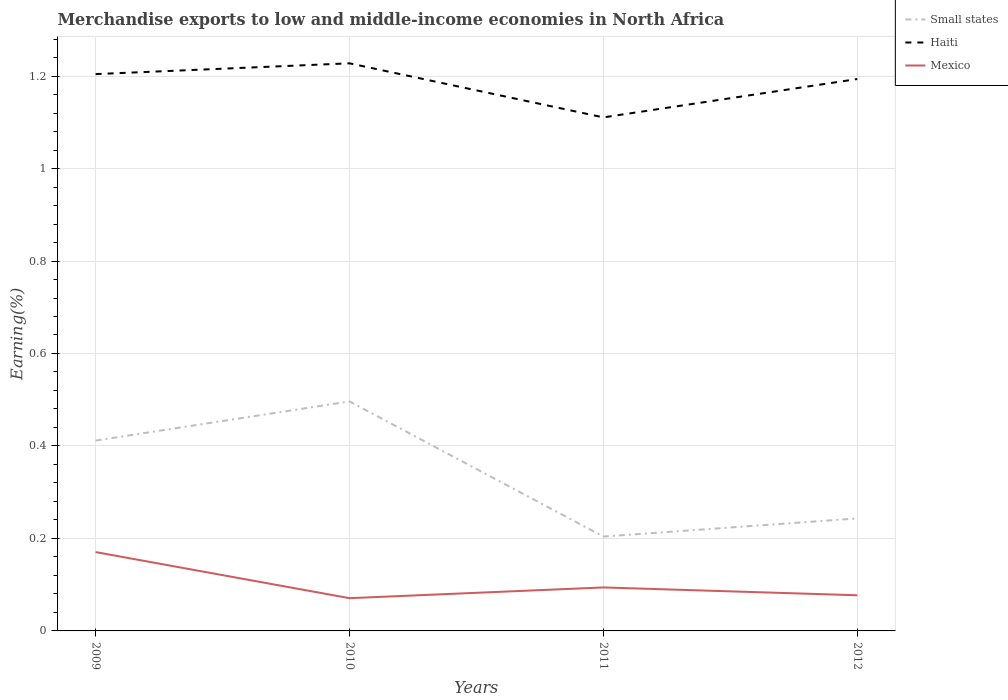Is the number of lines equal to the number of legend labels?
Provide a succinct answer. Yes. Across all years, what is the maximum percentage of amount earned from merchandise exports in Small states?
Make the answer very short. 0.2. In which year was the percentage of amount earned from merchandise exports in Haiti maximum?
Make the answer very short. 2011. What is the total percentage of amount earned from merchandise exports in Haiti in the graph?
Offer a very short reply. -0.02. What is the difference between the highest and the second highest percentage of amount earned from merchandise exports in Haiti?
Make the answer very short. 0.12. What is the difference between the highest and the lowest percentage of amount earned from merchandise exports in Small states?
Ensure brevity in your answer.  2. Is the percentage of amount earned from merchandise exports in Haiti strictly greater than the percentage of amount earned from merchandise exports in Small states over the years?
Your answer should be compact. No. How many lines are there?
Give a very brief answer. 3. Does the graph contain any zero values?
Provide a short and direct response. No. Where does the legend appear in the graph?
Your response must be concise. Top right. How many legend labels are there?
Ensure brevity in your answer.  3. What is the title of the graph?
Your answer should be compact. Merchandise exports to low and middle-income economies in North Africa. Does "Ghana" appear as one of the legend labels in the graph?
Ensure brevity in your answer.  No. What is the label or title of the Y-axis?
Give a very brief answer. Earning(%). What is the Earning(%) of Small states in 2009?
Your response must be concise. 0.41. What is the Earning(%) in Haiti in 2009?
Your answer should be compact. 1.2. What is the Earning(%) of Mexico in 2009?
Offer a very short reply. 0.17. What is the Earning(%) of Small states in 2010?
Make the answer very short. 0.5. What is the Earning(%) in Haiti in 2010?
Ensure brevity in your answer.  1.23. What is the Earning(%) of Mexico in 2010?
Make the answer very short. 0.07. What is the Earning(%) in Small states in 2011?
Provide a succinct answer. 0.2. What is the Earning(%) in Haiti in 2011?
Your answer should be very brief. 1.11. What is the Earning(%) in Mexico in 2011?
Give a very brief answer. 0.09. What is the Earning(%) of Small states in 2012?
Your answer should be compact. 0.24. What is the Earning(%) in Haiti in 2012?
Offer a terse response. 1.19. What is the Earning(%) of Mexico in 2012?
Your answer should be compact. 0.08. Across all years, what is the maximum Earning(%) of Small states?
Provide a short and direct response. 0.5. Across all years, what is the maximum Earning(%) in Haiti?
Your answer should be compact. 1.23. Across all years, what is the maximum Earning(%) in Mexico?
Give a very brief answer. 0.17. Across all years, what is the minimum Earning(%) in Small states?
Keep it short and to the point. 0.2. Across all years, what is the minimum Earning(%) of Haiti?
Your answer should be very brief. 1.11. Across all years, what is the minimum Earning(%) in Mexico?
Your answer should be very brief. 0.07. What is the total Earning(%) in Small states in the graph?
Your response must be concise. 1.36. What is the total Earning(%) in Haiti in the graph?
Give a very brief answer. 4.74. What is the total Earning(%) of Mexico in the graph?
Offer a very short reply. 0.41. What is the difference between the Earning(%) in Small states in 2009 and that in 2010?
Provide a succinct answer. -0.08. What is the difference between the Earning(%) in Haiti in 2009 and that in 2010?
Keep it short and to the point. -0.02. What is the difference between the Earning(%) in Mexico in 2009 and that in 2010?
Your answer should be compact. 0.1. What is the difference between the Earning(%) in Small states in 2009 and that in 2011?
Provide a short and direct response. 0.21. What is the difference between the Earning(%) in Haiti in 2009 and that in 2011?
Offer a very short reply. 0.09. What is the difference between the Earning(%) of Mexico in 2009 and that in 2011?
Provide a short and direct response. 0.08. What is the difference between the Earning(%) in Small states in 2009 and that in 2012?
Offer a terse response. 0.17. What is the difference between the Earning(%) of Haiti in 2009 and that in 2012?
Ensure brevity in your answer.  0.01. What is the difference between the Earning(%) of Mexico in 2009 and that in 2012?
Keep it short and to the point. 0.09. What is the difference between the Earning(%) of Small states in 2010 and that in 2011?
Offer a very short reply. 0.29. What is the difference between the Earning(%) of Haiti in 2010 and that in 2011?
Offer a terse response. 0.12. What is the difference between the Earning(%) of Mexico in 2010 and that in 2011?
Provide a succinct answer. -0.02. What is the difference between the Earning(%) of Small states in 2010 and that in 2012?
Keep it short and to the point. 0.25. What is the difference between the Earning(%) of Haiti in 2010 and that in 2012?
Ensure brevity in your answer.  0.03. What is the difference between the Earning(%) of Mexico in 2010 and that in 2012?
Ensure brevity in your answer.  -0.01. What is the difference between the Earning(%) of Small states in 2011 and that in 2012?
Offer a terse response. -0.04. What is the difference between the Earning(%) of Haiti in 2011 and that in 2012?
Your response must be concise. -0.08. What is the difference between the Earning(%) in Mexico in 2011 and that in 2012?
Ensure brevity in your answer.  0.02. What is the difference between the Earning(%) in Small states in 2009 and the Earning(%) in Haiti in 2010?
Keep it short and to the point. -0.82. What is the difference between the Earning(%) in Small states in 2009 and the Earning(%) in Mexico in 2010?
Your answer should be compact. 0.34. What is the difference between the Earning(%) of Haiti in 2009 and the Earning(%) of Mexico in 2010?
Provide a short and direct response. 1.13. What is the difference between the Earning(%) in Small states in 2009 and the Earning(%) in Haiti in 2011?
Provide a short and direct response. -0.7. What is the difference between the Earning(%) in Small states in 2009 and the Earning(%) in Mexico in 2011?
Provide a succinct answer. 0.32. What is the difference between the Earning(%) of Haiti in 2009 and the Earning(%) of Mexico in 2011?
Your answer should be very brief. 1.11. What is the difference between the Earning(%) of Small states in 2009 and the Earning(%) of Haiti in 2012?
Offer a terse response. -0.78. What is the difference between the Earning(%) of Small states in 2009 and the Earning(%) of Mexico in 2012?
Make the answer very short. 0.33. What is the difference between the Earning(%) of Haiti in 2009 and the Earning(%) of Mexico in 2012?
Your answer should be compact. 1.13. What is the difference between the Earning(%) of Small states in 2010 and the Earning(%) of Haiti in 2011?
Provide a succinct answer. -0.61. What is the difference between the Earning(%) in Small states in 2010 and the Earning(%) in Mexico in 2011?
Provide a short and direct response. 0.4. What is the difference between the Earning(%) in Haiti in 2010 and the Earning(%) in Mexico in 2011?
Provide a short and direct response. 1.13. What is the difference between the Earning(%) of Small states in 2010 and the Earning(%) of Haiti in 2012?
Your answer should be very brief. -0.7. What is the difference between the Earning(%) of Small states in 2010 and the Earning(%) of Mexico in 2012?
Ensure brevity in your answer.  0.42. What is the difference between the Earning(%) of Haiti in 2010 and the Earning(%) of Mexico in 2012?
Make the answer very short. 1.15. What is the difference between the Earning(%) of Small states in 2011 and the Earning(%) of Haiti in 2012?
Give a very brief answer. -0.99. What is the difference between the Earning(%) of Small states in 2011 and the Earning(%) of Mexico in 2012?
Your answer should be very brief. 0.13. What is the difference between the Earning(%) of Haiti in 2011 and the Earning(%) of Mexico in 2012?
Ensure brevity in your answer.  1.03. What is the average Earning(%) of Small states per year?
Provide a short and direct response. 0.34. What is the average Earning(%) in Haiti per year?
Give a very brief answer. 1.18. What is the average Earning(%) in Mexico per year?
Your answer should be compact. 0.1. In the year 2009, what is the difference between the Earning(%) in Small states and Earning(%) in Haiti?
Your response must be concise. -0.79. In the year 2009, what is the difference between the Earning(%) of Small states and Earning(%) of Mexico?
Your answer should be very brief. 0.24. In the year 2009, what is the difference between the Earning(%) in Haiti and Earning(%) in Mexico?
Offer a very short reply. 1.03. In the year 2010, what is the difference between the Earning(%) of Small states and Earning(%) of Haiti?
Your response must be concise. -0.73. In the year 2010, what is the difference between the Earning(%) of Small states and Earning(%) of Mexico?
Ensure brevity in your answer.  0.43. In the year 2010, what is the difference between the Earning(%) in Haiti and Earning(%) in Mexico?
Provide a short and direct response. 1.16. In the year 2011, what is the difference between the Earning(%) of Small states and Earning(%) of Haiti?
Your answer should be compact. -0.91. In the year 2011, what is the difference between the Earning(%) in Small states and Earning(%) in Mexico?
Provide a short and direct response. 0.11. In the year 2011, what is the difference between the Earning(%) of Haiti and Earning(%) of Mexico?
Your answer should be very brief. 1.02. In the year 2012, what is the difference between the Earning(%) of Small states and Earning(%) of Haiti?
Your answer should be very brief. -0.95. In the year 2012, what is the difference between the Earning(%) of Small states and Earning(%) of Mexico?
Make the answer very short. 0.17. In the year 2012, what is the difference between the Earning(%) in Haiti and Earning(%) in Mexico?
Provide a short and direct response. 1.12. What is the ratio of the Earning(%) of Small states in 2009 to that in 2010?
Give a very brief answer. 0.83. What is the ratio of the Earning(%) in Haiti in 2009 to that in 2010?
Your answer should be very brief. 0.98. What is the ratio of the Earning(%) in Mexico in 2009 to that in 2010?
Provide a succinct answer. 2.41. What is the ratio of the Earning(%) of Small states in 2009 to that in 2011?
Offer a very short reply. 2.02. What is the ratio of the Earning(%) of Haiti in 2009 to that in 2011?
Your response must be concise. 1.08. What is the ratio of the Earning(%) in Mexico in 2009 to that in 2011?
Make the answer very short. 1.81. What is the ratio of the Earning(%) in Small states in 2009 to that in 2012?
Your answer should be compact. 1.69. What is the ratio of the Earning(%) of Haiti in 2009 to that in 2012?
Provide a short and direct response. 1.01. What is the ratio of the Earning(%) in Mexico in 2009 to that in 2012?
Your response must be concise. 2.21. What is the ratio of the Earning(%) of Small states in 2010 to that in 2011?
Provide a short and direct response. 2.43. What is the ratio of the Earning(%) in Haiti in 2010 to that in 2011?
Provide a succinct answer. 1.11. What is the ratio of the Earning(%) in Mexico in 2010 to that in 2011?
Make the answer very short. 0.75. What is the ratio of the Earning(%) in Small states in 2010 to that in 2012?
Your answer should be compact. 2.04. What is the ratio of the Earning(%) in Haiti in 2010 to that in 2012?
Ensure brevity in your answer.  1.03. What is the ratio of the Earning(%) in Mexico in 2010 to that in 2012?
Provide a short and direct response. 0.92. What is the ratio of the Earning(%) in Small states in 2011 to that in 2012?
Ensure brevity in your answer.  0.84. What is the ratio of the Earning(%) in Haiti in 2011 to that in 2012?
Provide a short and direct response. 0.93. What is the ratio of the Earning(%) of Mexico in 2011 to that in 2012?
Keep it short and to the point. 1.22. What is the difference between the highest and the second highest Earning(%) of Small states?
Provide a succinct answer. 0.08. What is the difference between the highest and the second highest Earning(%) in Haiti?
Give a very brief answer. 0.02. What is the difference between the highest and the second highest Earning(%) of Mexico?
Offer a very short reply. 0.08. What is the difference between the highest and the lowest Earning(%) of Small states?
Give a very brief answer. 0.29. What is the difference between the highest and the lowest Earning(%) in Haiti?
Keep it short and to the point. 0.12. What is the difference between the highest and the lowest Earning(%) of Mexico?
Give a very brief answer. 0.1. 